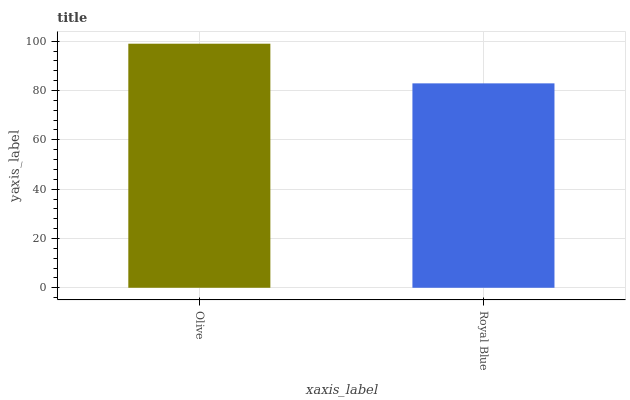Is Royal Blue the minimum?
Answer yes or no. Yes. Is Olive the maximum?
Answer yes or no. Yes. Is Royal Blue the maximum?
Answer yes or no. No. Is Olive greater than Royal Blue?
Answer yes or no. Yes. Is Royal Blue less than Olive?
Answer yes or no. Yes. Is Royal Blue greater than Olive?
Answer yes or no. No. Is Olive less than Royal Blue?
Answer yes or no. No. Is Olive the high median?
Answer yes or no. Yes. Is Royal Blue the low median?
Answer yes or no. Yes. Is Royal Blue the high median?
Answer yes or no. No. Is Olive the low median?
Answer yes or no. No. 